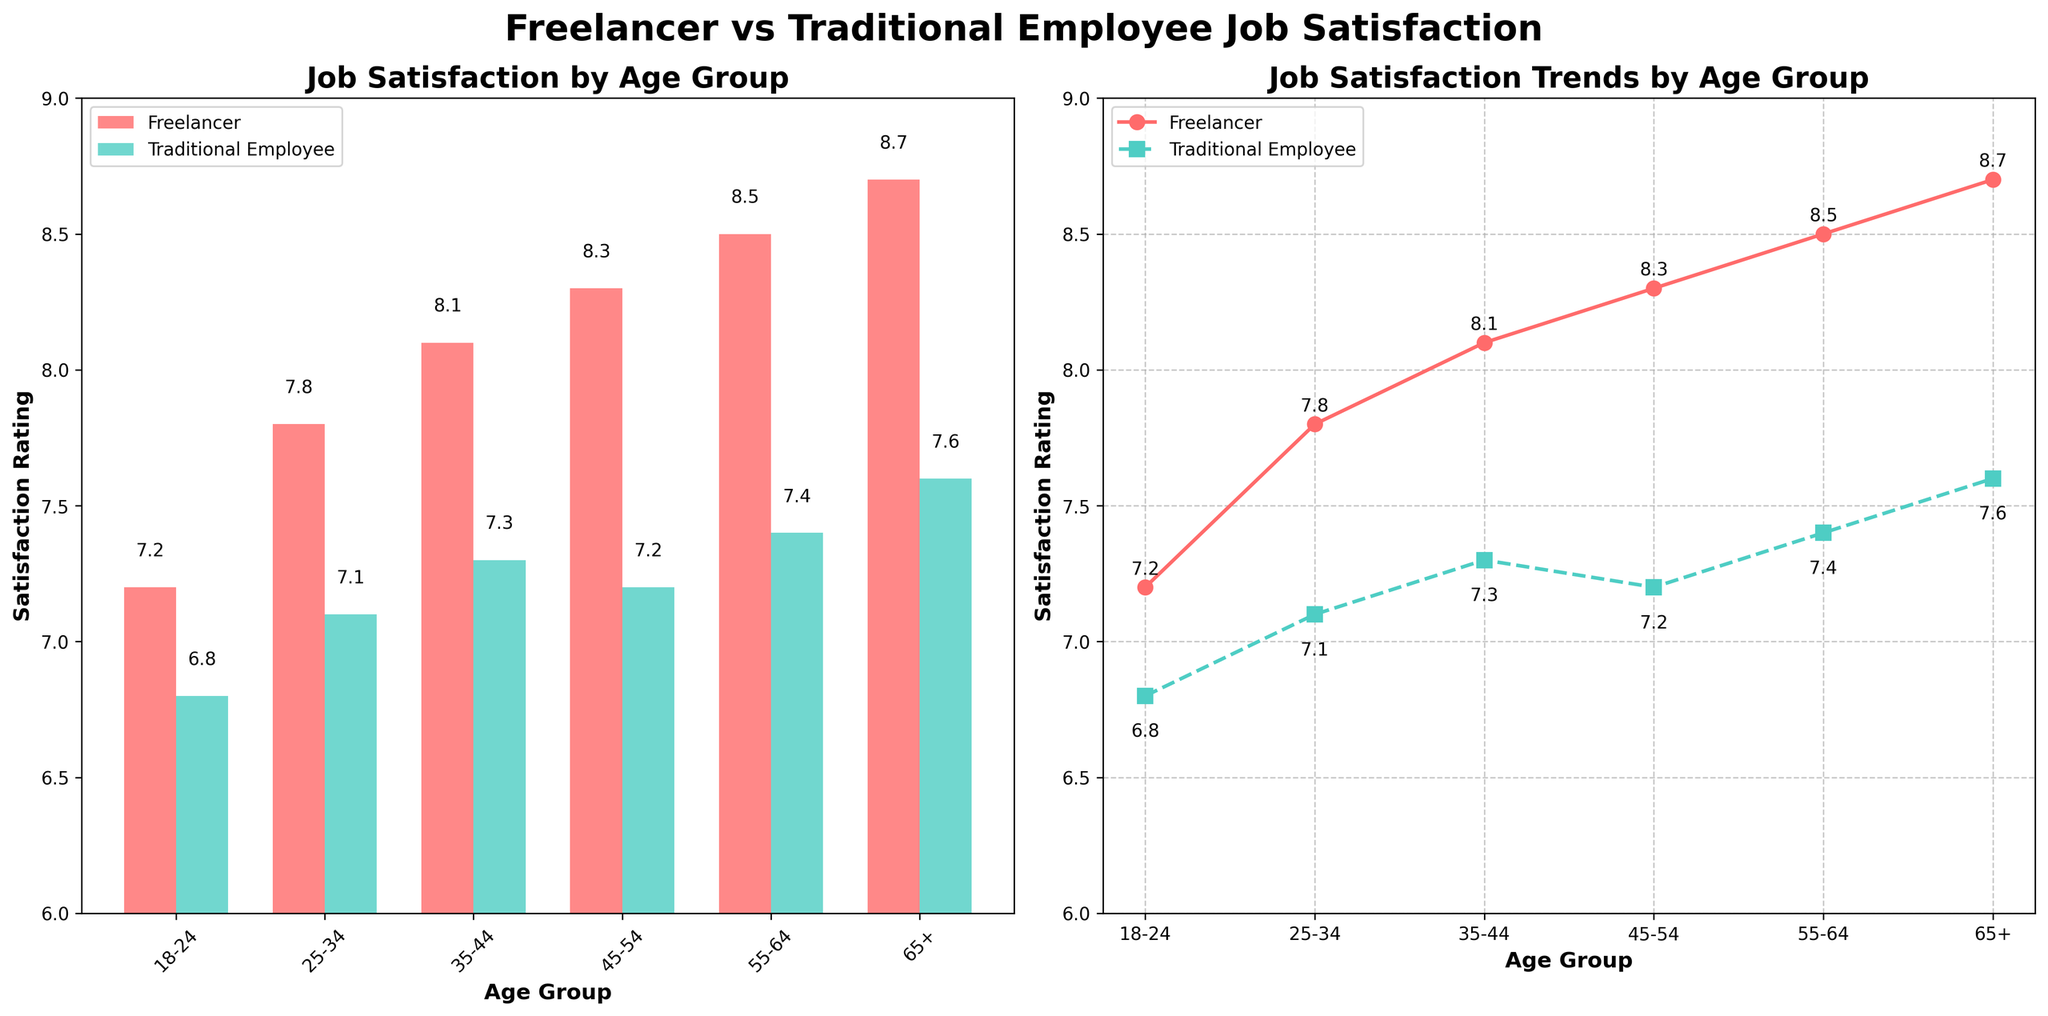What is the difference in job satisfaction ratings between freelancers and traditional employees in the 18-24 age group? In the 18-24 age group, freelancers have a satisfaction rating of 7.2, while traditional employees have a rating of 6.8. The difference is 7.2 - 6.8
Answer: 0.4 Which age group has the highest job satisfaction rating for freelancers? The line chart shows the job satisfaction ratings for freelancers across different age groups. The 65+ age group has the highest rating of 8.7
Answer: 65+ How does the job satisfaction rating for traditional employees change from the 25-34 age group to the 45-54 age group? The line chart shows that for traditional employees, the rating is 7.1 for the 25-34 age group and it increases to 7.2 for the 45-54 age group
Answer: It increases Compared to freelancers, which age group sees the smallest difference in job satisfaction ratings with traditional employees? The smallest difference in ratings can be seen in the 45-54 age group. Freelancers have a rating of 8.3 and traditional employees have a rating of 7.2. The difference is 8.3 - 7.2 = 1.1
Answer: 45-54 What is the average job satisfaction rating for freelancers across all age groups? The freelancer satisfaction ratings are 7.2, 7.8, 8.1, 8.3, 8.5, 8.7. Sum these ratings and divide by 6: (7.2 + 7.8 + 8.1 + 8.3 + 8.5 + 8.7) / 6 = 48.6/6
Answer: 8.1 Between which two consecutive age groups is the increase in freelancer satisfaction the highest? The highest increase is from the 55-64 age group to the 65+ age group. The rating goes from 8.5 to 8.7, an increase of 0.2
Answer: 55-64 to 65+ What visual cue indicates the higher job satisfaction ratings among freelancers in the bar chart? In the bar chart, Freelancer satisfaction bars (in red) are generally taller than Traditional Employee satisfaction bars (in blue) across all age groups
Answer: Taller bars How do the job satisfaction trends for freelancers and traditional employees diverge as age increases? In the line chart, job satisfaction for freelancers shows a consistent, gradual increase with age, whereas traditional employees' satisfaction has a slower and less consistent increase
Answer: Freelancers rise steadily, Traditional employees rise less consistently Which age group shows a decline or stagnant change in job satisfaction when comparing consecutive groups for traditional employees? The 45-54 age group has a rating of 7.2, which shows a slight decline from the 35-44 age group's rating of 7.3
Answer: 45-54 How much higher is the freelancer satisfaction rating compared to traditional employees in the 55-64 age group? The freelancer satisfaction rating in the 55-64 age group is 8.5, and for traditional employees, it is 7.4. The difference is 8.5 - 7.4
Answer: 1.1 